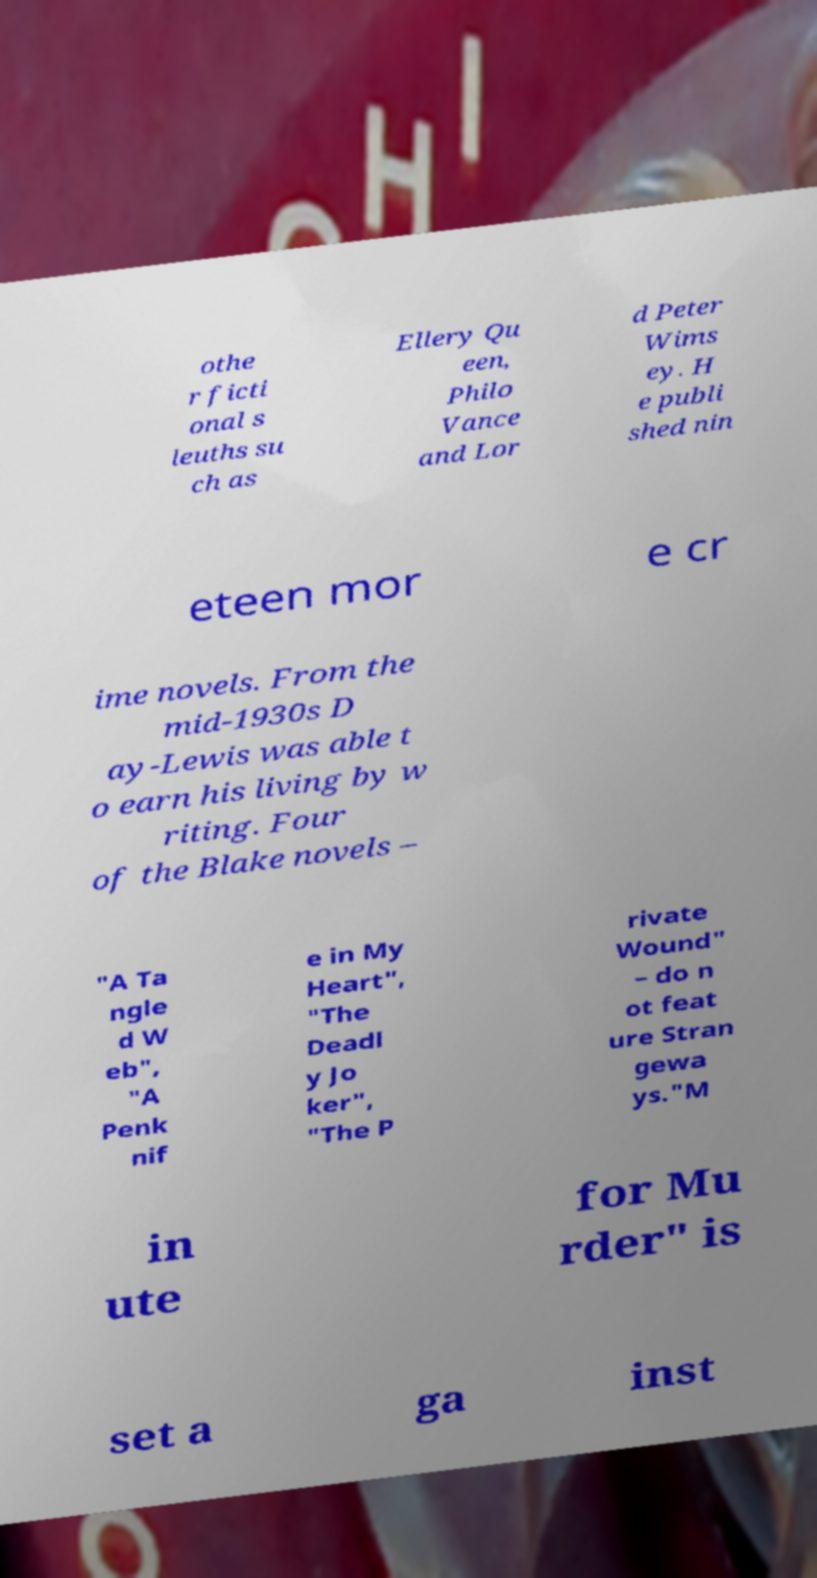Please identify and transcribe the text found in this image. othe r ficti onal s leuths su ch as Ellery Qu een, Philo Vance and Lor d Peter Wims ey. H e publi shed nin eteen mor e cr ime novels. From the mid-1930s D ay-Lewis was able t o earn his living by w riting. Four of the Blake novels – "A Ta ngle d W eb", "A Penk nif e in My Heart", "The Deadl y Jo ker", "The P rivate Wound" – do n ot feat ure Stran gewa ys."M in ute for Mu rder" is set a ga inst 